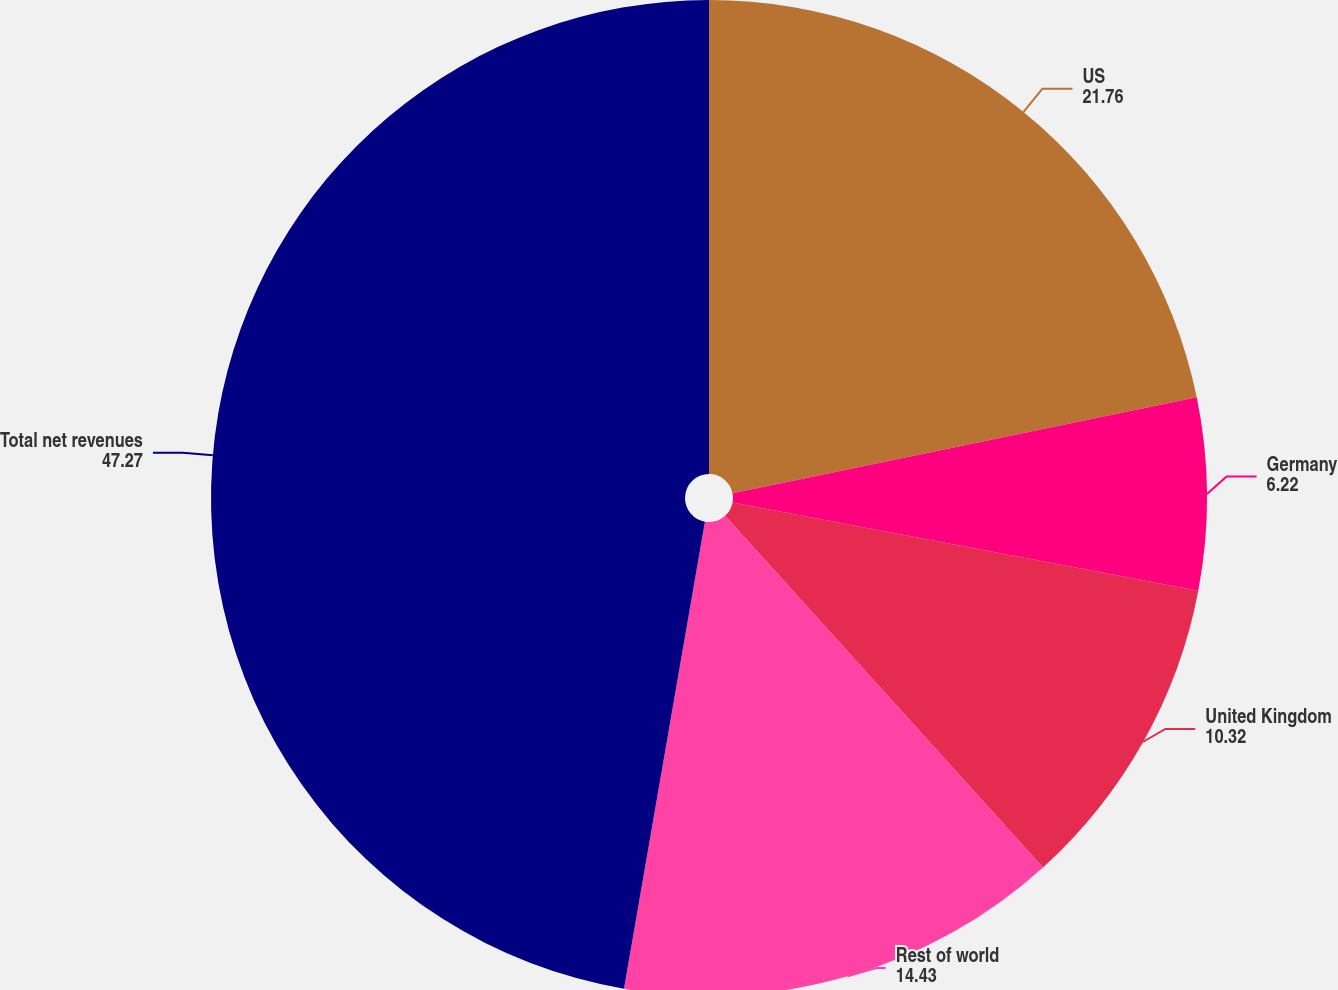<chart> <loc_0><loc_0><loc_500><loc_500><pie_chart><fcel>US<fcel>Germany<fcel>United Kingdom<fcel>Rest of world<fcel>Total net revenues<nl><fcel>21.76%<fcel>6.22%<fcel>10.32%<fcel>14.43%<fcel>47.27%<nl></chart> 